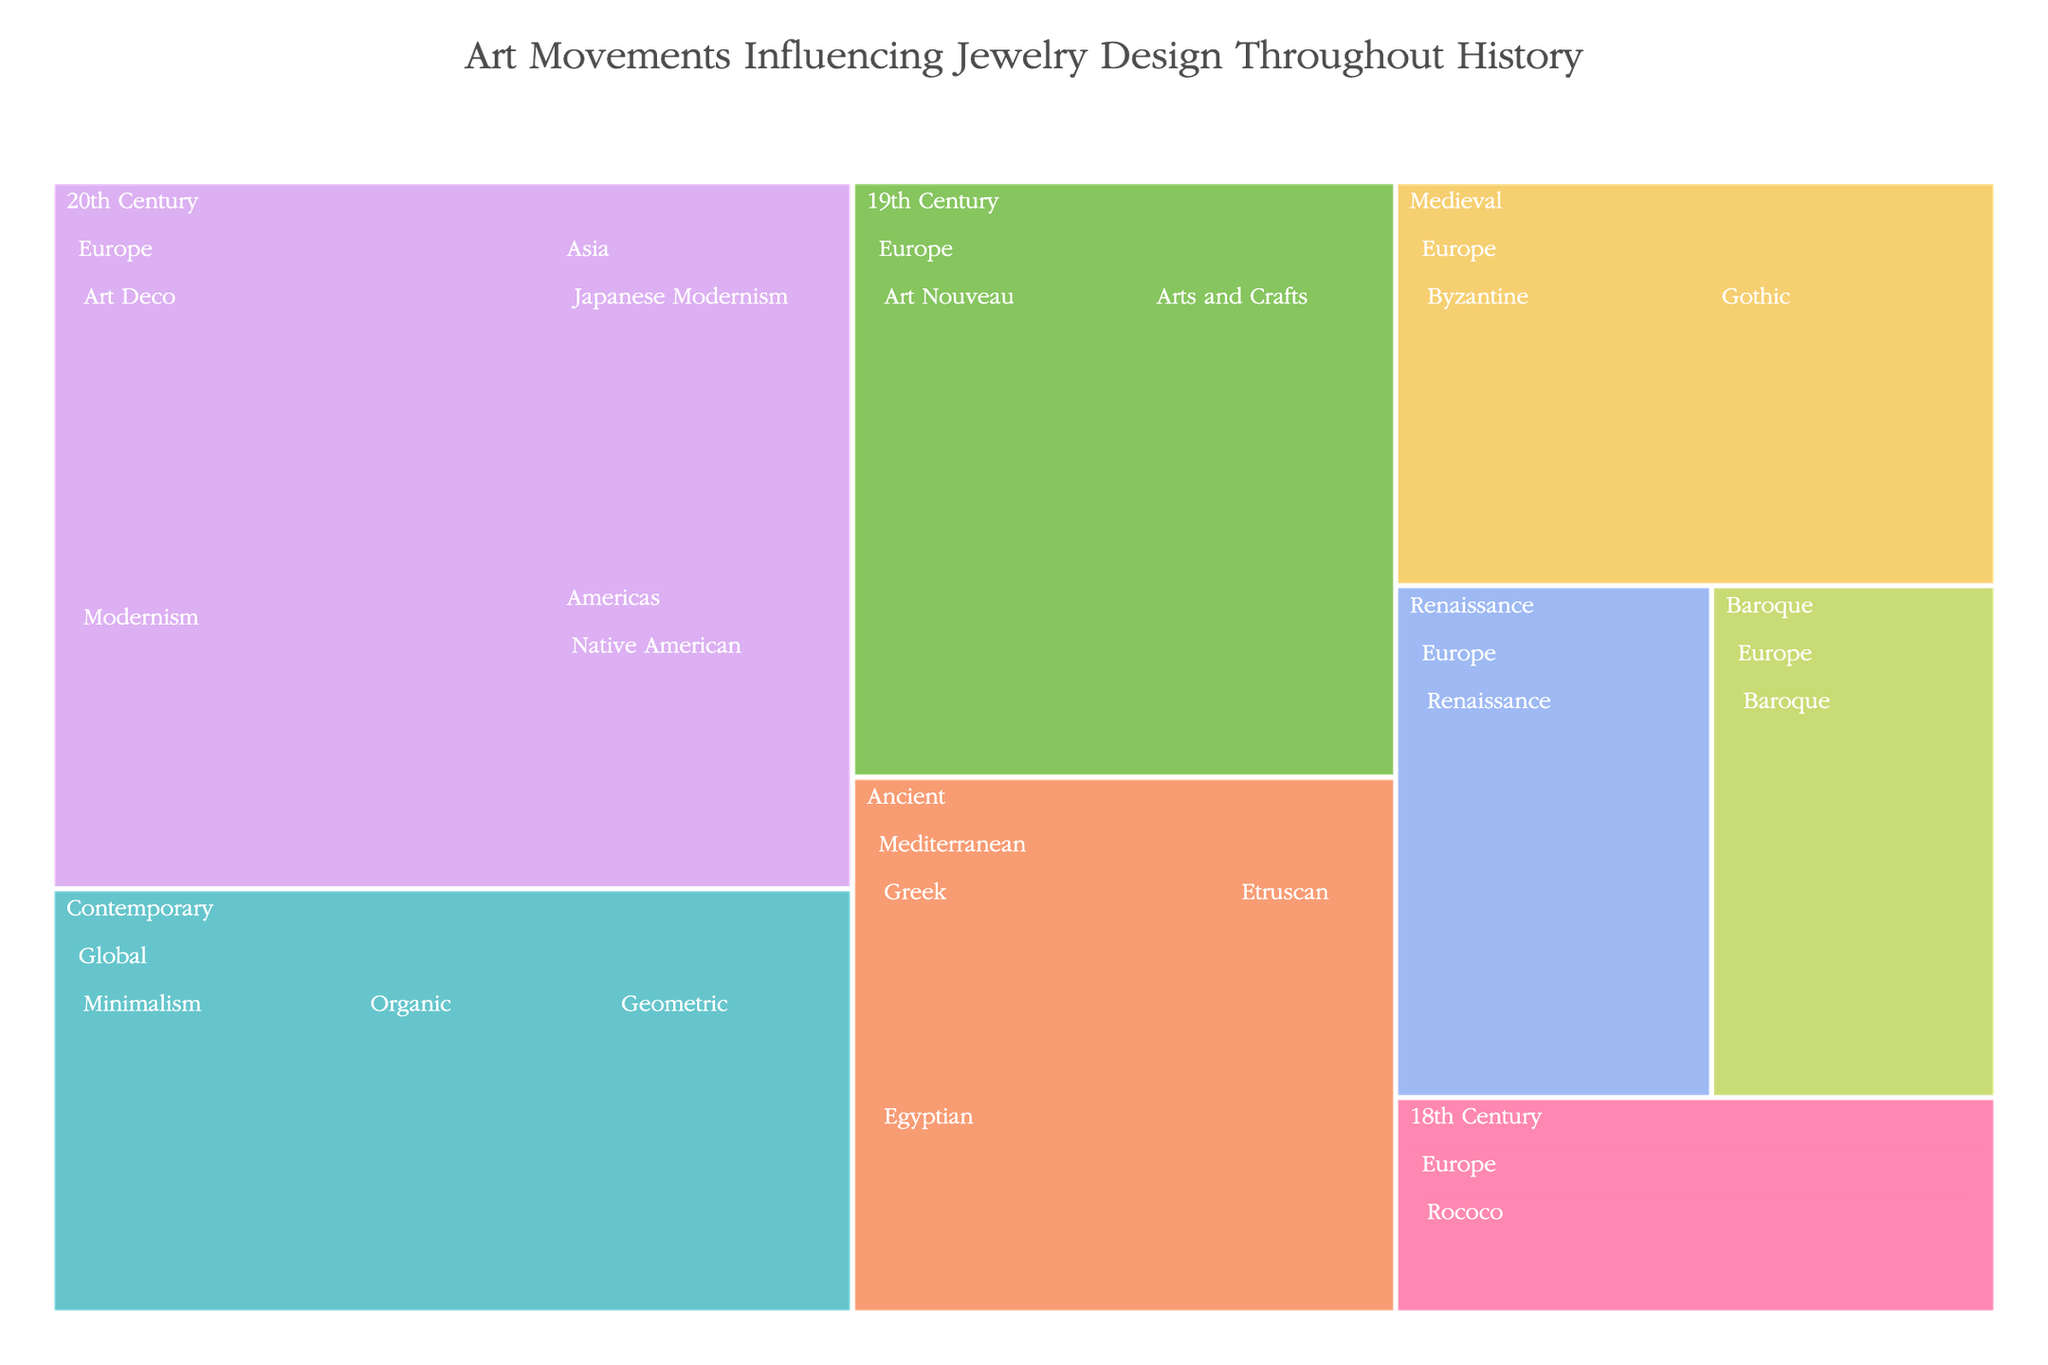What is the title of the treemap? The title is prominently displayed at the top center of the treemap.
Answer: Art Movements Influencing Jewelry Design Throughout History Which time period has the highest influence in jewelry design? To determine this, examine the size of the largest sections corresponding to each time period.
Answer: 20th Century Which region in the Ancient period has the highest influence in jewelry design? Look at the segments within the Ancient time period and compare their sizes.
Answer: Mediterranean How does the influence of Art Deco compare to Art Nouveau? Locate both Art Deco and Art Nouveau in the 20th Century period and compare their sizes. Art Deco has an influence of 60, while Art Nouveau has 55, making Art Deco the more influential.
Answer: Art Deco has a higher influence What is the combined influence of Renaissance and Baroque art movements? Identify the influence values of Renaissance (50) and Baroque (45) in the Renaissance and Baroque periods respectively, then sum them. 50 + 45 = 95
Answer: 95 What are the regions represented in the 20th Century time period? Check the segments under the 20th Century time period for different region labels.
Answer: Europe, Americas, Asia Which time period has the least combined influence on jewelry design, and what is that influence? Sum the influence values for each time period and compare them to identify the smallest total.
Answer: Ancient (90) Within the Medieval period, which art movement had a greater influence and by how much? Compare the influence values of the Byzantine (40) and Gothic (35) art movements. The Byzantine period had a greater influence by 5.
Answer: Byzantine, by 5 How do the influences of Minimalism and Organic compare in the Contemporary period? Observe the segments for Minimalism (40) and Organic (35) in the Contemporary time period and compare their sizes. Minimalism has a higher influence value.
Answer: Minimalism has a higher influence What is the average influence value of the art movements within the 20th Century from Europe? Identify the influence values of Art Deco (60), Modernism (50), and sum them up, then divide by the number of movements. (60 + 50) / 2 = 55
Answer: 55 